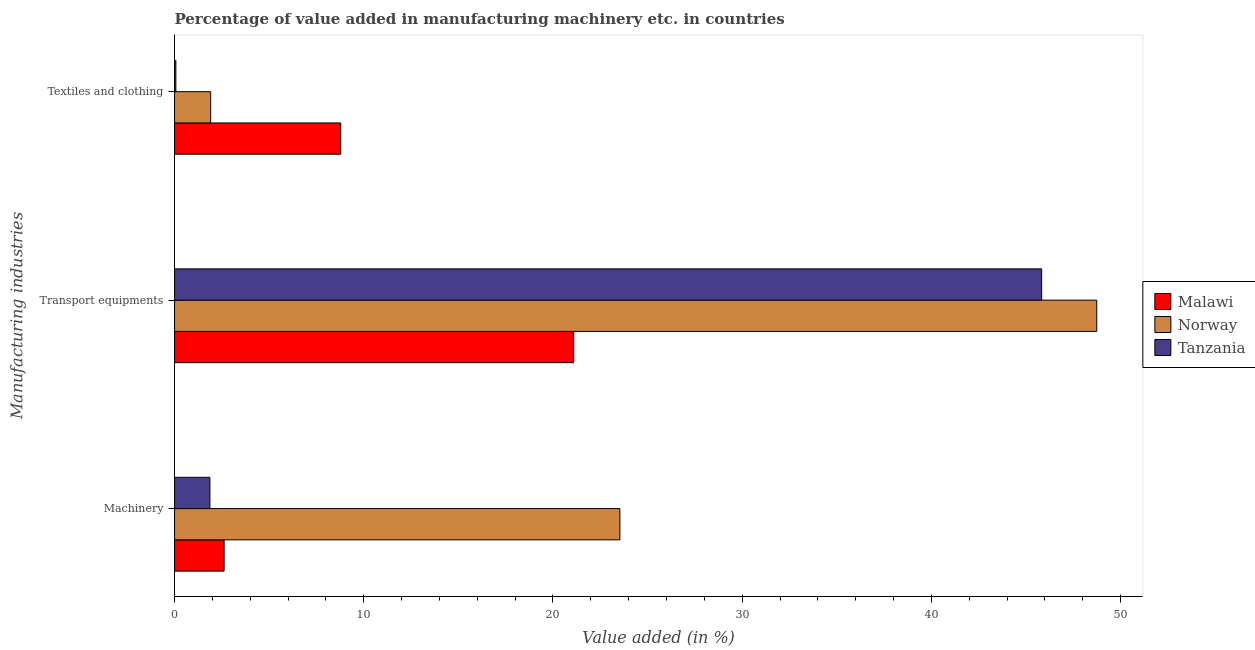How many different coloured bars are there?
Ensure brevity in your answer.  3. What is the label of the 2nd group of bars from the top?
Make the answer very short. Transport equipments. What is the value added in manufacturing transport equipments in Tanzania?
Provide a succinct answer. 45.83. Across all countries, what is the maximum value added in manufacturing machinery?
Your response must be concise. 23.54. Across all countries, what is the minimum value added in manufacturing machinery?
Offer a terse response. 1.87. In which country was the value added in manufacturing transport equipments maximum?
Provide a succinct answer. Norway. In which country was the value added in manufacturing machinery minimum?
Provide a succinct answer. Tanzania. What is the total value added in manufacturing textile and clothing in the graph?
Your response must be concise. 10.76. What is the difference between the value added in manufacturing transport equipments in Norway and that in Malawi?
Ensure brevity in your answer.  27.64. What is the difference between the value added in manufacturing textile and clothing in Malawi and the value added in manufacturing machinery in Norway?
Keep it short and to the point. -14.75. What is the average value added in manufacturing transport equipments per country?
Offer a very short reply. 38.55. What is the difference between the value added in manufacturing textile and clothing and value added in manufacturing transport equipments in Norway?
Make the answer very short. -46.83. What is the ratio of the value added in manufacturing machinery in Norway to that in Malawi?
Offer a very short reply. 8.99. Is the value added in manufacturing machinery in Tanzania less than that in Malawi?
Give a very brief answer. Yes. What is the difference between the highest and the second highest value added in manufacturing machinery?
Make the answer very short. 20.92. What is the difference between the highest and the lowest value added in manufacturing transport equipments?
Your response must be concise. 27.64. Is the sum of the value added in manufacturing machinery in Malawi and Tanzania greater than the maximum value added in manufacturing textile and clothing across all countries?
Keep it short and to the point. No. What does the 2nd bar from the bottom in Machinery represents?
Keep it short and to the point. Norway. How many bars are there?
Provide a succinct answer. 9. How many countries are there in the graph?
Ensure brevity in your answer.  3. Are the values on the major ticks of X-axis written in scientific E-notation?
Make the answer very short. No. Does the graph contain any zero values?
Ensure brevity in your answer.  No. Where does the legend appear in the graph?
Keep it short and to the point. Center right. What is the title of the graph?
Offer a terse response. Percentage of value added in manufacturing machinery etc. in countries. What is the label or title of the X-axis?
Ensure brevity in your answer.  Value added (in %). What is the label or title of the Y-axis?
Offer a terse response. Manufacturing industries. What is the Value added (in %) in Malawi in Machinery?
Your answer should be compact. 2.62. What is the Value added (in %) of Norway in Machinery?
Your response must be concise. 23.54. What is the Value added (in %) in Tanzania in Machinery?
Offer a terse response. 1.87. What is the Value added (in %) of Malawi in Transport equipments?
Give a very brief answer. 21.09. What is the Value added (in %) of Norway in Transport equipments?
Provide a short and direct response. 48.74. What is the Value added (in %) of Tanzania in Transport equipments?
Your answer should be compact. 45.83. What is the Value added (in %) in Malawi in Textiles and clothing?
Give a very brief answer. 8.78. What is the Value added (in %) in Norway in Textiles and clothing?
Provide a succinct answer. 1.91. What is the Value added (in %) of Tanzania in Textiles and clothing?
Offer a very short reply. 0.07. Across all Manufacturing industries, what is the maximum Value added (in %) of Malawi?
Give a very brief answer. 21.09. Across all Manufacturing industries, what is the maximum Value added (in %) in Norway?
Your answer should be compact. 48.74. Across all Manufacturing industries, what is the maximum Value added (in %) of Tanzania?
Give a very brief answer. 45.83. Across all Manufacturing industries, what is the minimum Value added (in %) in Malawi?
Give a very brief answer. 2.62. Across all Manufacturing industries, what is the minimum Value added (in %) of Norway?
Provide a succinct answer. 1.91. Across all Manufacturing industries, what is the minimum Value added (in %) of Tanzania?
Keep it short and to the point. 0.07. What is the total Value added (in %) of Malawi in the graph?
Your response must be concise. 32.5. What is the total Value added (in %) in Norway in the graph?
Make the answer very short. 74.18. What is the total Value added (in %) in Tanzania in the graph?
Offer a terse response. 47.77. What is the difference between the Value added (in %) of Malawi in Machinery and that in Transport equipments?
Provide a short and direct response. -18.47. What is the difference between the Value added (in %) in Norway in Machinery and that in Transport equipments?
Your answer should be very brief. -25.2. What is the difference between the Value added (in %) of Tanzania in Machinery and that in Transport equipments?
Your response must be concise. -43.96. What is the difference between the Value added (in %) in Malawi in Machinery and that in Textiles and clothing?
Keep it short and to the point. -6.16. What is the difference between the Value added (in %) of Norway in Machinery and that in Textiles and clothing?
Make the answer very short. 21.63. What is the difference between the Value added (in %) of Tanzania in Machinery and that in Textiles and clothing?
Make the answer very short. 1.8. What is the difference between the Value added (in %) in Malawi in Transport equipments and that in Textiles and clothing?
Offer a very short reply. 12.31. What is the difference between the Value added (in %) of Norway in Transport equipments and that in Textiles and clothing?
Keep it short and to the point. 46.83. What is the difference between the Value added (in %) of Tanzania in Transport equipments and that in Textiles and clothing?
Your answer should be compact. 45.76. What is the difference between the Value added (in %) of Malawi in Machinery and the Value added (in %) of Norway in Transport equipments?
Offer a terse response. -46.12. What is the difference between the Value added (in %) in Malawi in Machinery and the Value added (in %) in Tanzania in Transport equipments?
Give a very brief answer. -43.21. What is the difference between the Value added (in %) of Norway in Machinery and the Value added (in %) of Tanzania in Transport equipments?
Provide a succinct answer. -22.29. What is the difference between the Value added (in %) in Malawi in Machinery and the Value added (in %) in Norway in Textiles and clothing?
Provide a succinct answer. 0.71. What is the difference between the Value added (in %) of Malawi in Machinery and the Value added (in %) of Tanzania in Textiles and clothing?
Your answer should be very brief. 2.55. What is the difference between the Value added (in %) of Norway in Machinery and the Value added (in %) of Tanzania in Textiles and clothing?
Keep it short and to the point. 23.47. What is the difference between the Value added (in %) of Malawi in Transport equipments and the Value added (in %) of Norway in Textiles and clothing?
Keep it short and to the point. 19.18. What is the difference between the Value added (in %) in Malawi in Transport equipments and the Value added (in %) in Tanzania in Textiles and clothing?
Make the answer very short. 21.02. What is the difference between the Value added (in %) of Norway in Transport equipments and the Value added (in %) of Tanzania in Textiles and clothing?
Your answer should be compact. 48.67. What is the average Value added (in %) of Malawi per Manufacturing industries?
Give a very brief answer. 10.83. What is the average Value added (in %) of Norway per Manufacturing industries?
Your response must be concise. 24.73. What is the average Value added (in %) of Tanzania per Manufacturing industries?
Provide a succinct answer. 15.92. What is the difference between the Value added (in %) in Malawi and Value added (in %) in Norway in Machinery?
Your response must be concise. -20.92. What is the difference between the Value added (in %) in Malawi and Value added (in %) in Tanzania in Machinery?
Offer a very short reply. 0.75. What is the difference between the Value added (in %) of Norway and Value added (in %) of Tanzania in Machinery?
Ensure brevity in your answer.  21.67. What is the difference between the Value added (in %) in Malawi and Value added (in %) in Norway in Transport equipments?
Give a very brief answer. -27.64. What is the difference between the Value added (in %) in Malawi and Value added (in %) in Tanzania in Transport equipments?
Keep it short and to the point. -24.73. What is the difference between the Value added (in %) in Norway and Value added (in %) in Tanzania in Transport equipments?
Offer a very short reply. 2.91. What is the difference between the Value added (in %) of Malawi and Value added (in %) of Norway in Textiles and clothing?
Your answer should be very brief. 6.87. What is the difference between the Value added (in %) of Malawi and Value added (in %) of Tanzania in Textiles and clothing?
Provide a short and direct response. 8.71. What is the difference between the Value added (in %) of Norway and Value added (in %) of Tanzania in Textiles and clothing?
Provide a succinct answer. 1.84. What is the ratio of the Value added (in %) in Malawi in Machinery to that in Transport equipments?
Make the answer very short. 0.12. What is the ratio of the Value added (in %) of Norway in Machinery to that in Transport equipments?
Your response must be concise. 0.48. What is the ratio of the Value added (in %) of Tanzania in Machinery to that in Transport equipments?
Keep it short and to the point. 0.04. What is the ratio of the Value added (in %) in Malawi in Machinery to that in Textiles and clothing?
Offer a terse response. 0.3. What is the ratio of the Value added (in %) of Norway in Machinery to that in Textiles and clothing?
Provide a short and direct response. 12.32. What is the ratio of the Value added (in %) in Tanzania in Machinery to that in Textiles and clothing?
Offer a very short reply. 26.74. What is the ratio of the Value added (in %) in Malawi in Transport equipments to that in Textiles and clothing?
Provide a succinct answer. 2.4. What is the ratio of the Value added (in %) of Norway in Transport equipments to that in Textiles and clothing?
Give a very brief answer. 25.52. What is the ratio of the Value added (in %) of Tanzania in Transport equipments to that in Textiles and clothing?
Offer a terse response. 655.68. What is the difference between the highest and the second highest Value added (in %) in Malawi?
Your response must be concise. 12.31. What is the difference between the highest and the second highest Value added (in %) of Norway?
Your response must be concise. 25.2. What is the difference between the highest and the second highest Value added (in %) in Tanzania?
Provide a short and direct response. 43.96. What is the difference between the highest and the lowest Value added (in %) of Malawi?
Keep it short and to the point. 18.47. What is the difference between the highest and the lowest Value added (in %) in Norway?
Your answer should be very brief. 46.83. What is the difference between the highest and the lowest Value added (in %) in Tanzania?
Give a very brief answer. 45.76. 